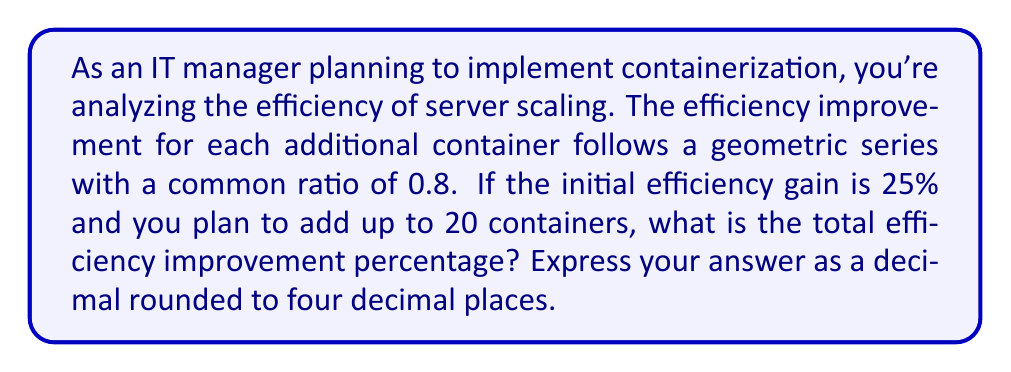Give your solution to this math problem. Let's approach this step-by-step using the properties of geometric series:

1) First, we identify the components of our geometric series:
   - Initial term, $a = 0.25$ (25% expressed as a decimal)
   - Common ratio, $r = 0.8$
   - Number of terms, $n = 20$

2) The formula for the sum of a geometric series is:

   $$S_n = \frac{a(1-r^n)}{1-r}$$

   Where $S_n$ is the sum of the first $n$ terms.

3) Let's substitute our values:

   $$S_{20} = \frac{0.25(1-0.8^{20})}{1-0.8}$$

4) Simplify:
   
   $$S_{20} = \frac{0.25(1-0.0115)}{0.2}$$

5) Calculate:

   $$S_{20} = \frac{0.25(0.9885)}{0.2} = 1.2356$$

6) This result represents the total efficiency improvement factor. To convert it to a percentage, we subtract 1 and multiply by 100:

   $$(1.2356 - 1) * 100 = 23.56\%$$

7) Rounded to four decimal places: 0.2356

This means the total efficiency improvement after adding 20 containers is approximately 23.56% or 0.2356 when expressed as a decimal.
Answer: 0.2356 